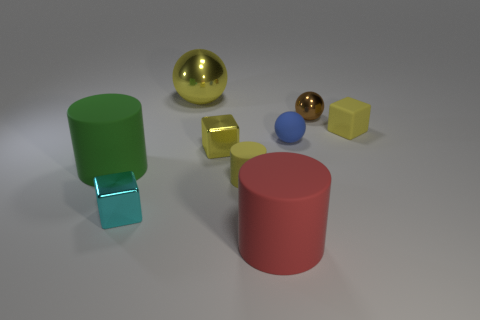Subtract all cyan cubes. Subtract all cyan balls. How many cubes are left? 2 Add 1 cylinders. How many objects exist? 10 Subtract all blocks. How many objects are left? 6 Subtract 0 purple cylinders. How many objects are left? 9 Subtract all big red cylinders. Subtract all red matte cylinders. How many objects are left? 7 Add 8 cyan things. How many cyan things are left? 9 Add 2 tiny matte spheres. How many tiny matte spheres exist? 3 